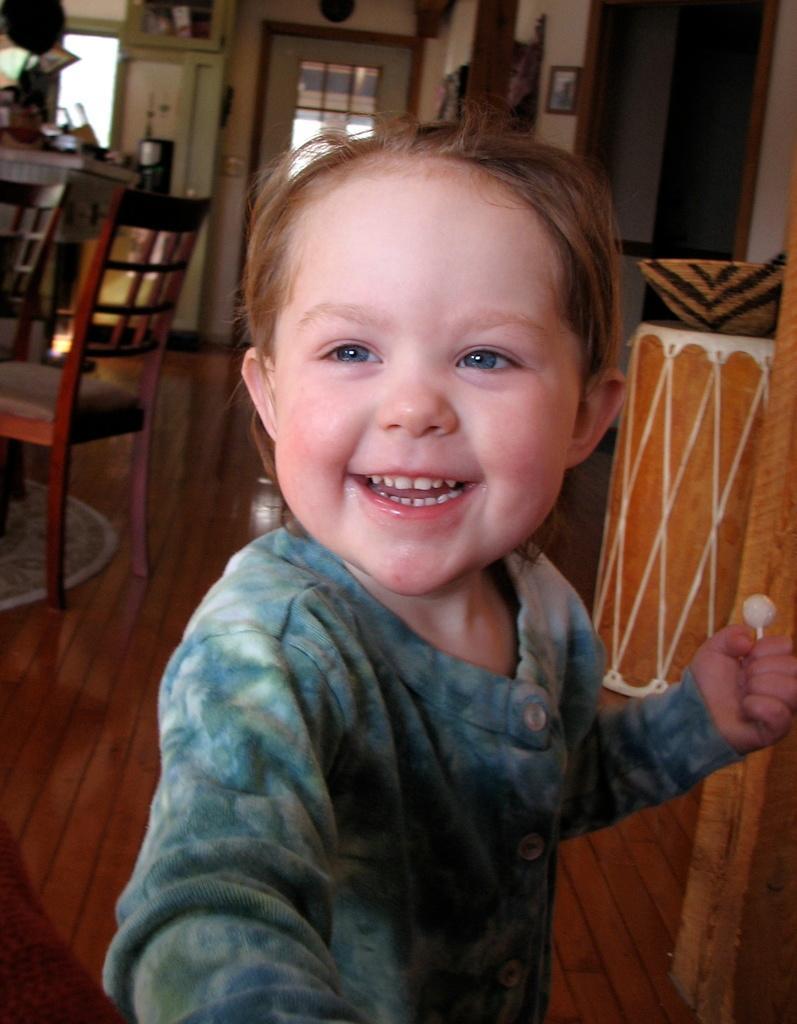In one or two sentences, can you explain what this image depicts? In this image i can see inside view of house. And on the middle a baby stand on the floor and she is smiling and she is wearing a blue color jacket and holding a lollipop on right hand side. And right of the image there are some objects kept on the floor. and i can see a wall ,on the wall there is a photo frame attached to the wall. And on the right corner there is a window. On the left there is a table kept on the floor and there is a chair o the floor and there are some objects kept on the floor. 